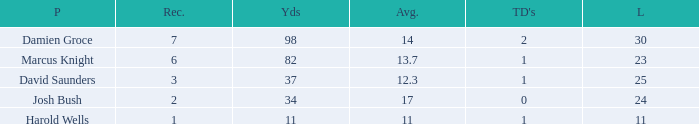How many TDs are there were the long is smaller than 23? 1.0. 